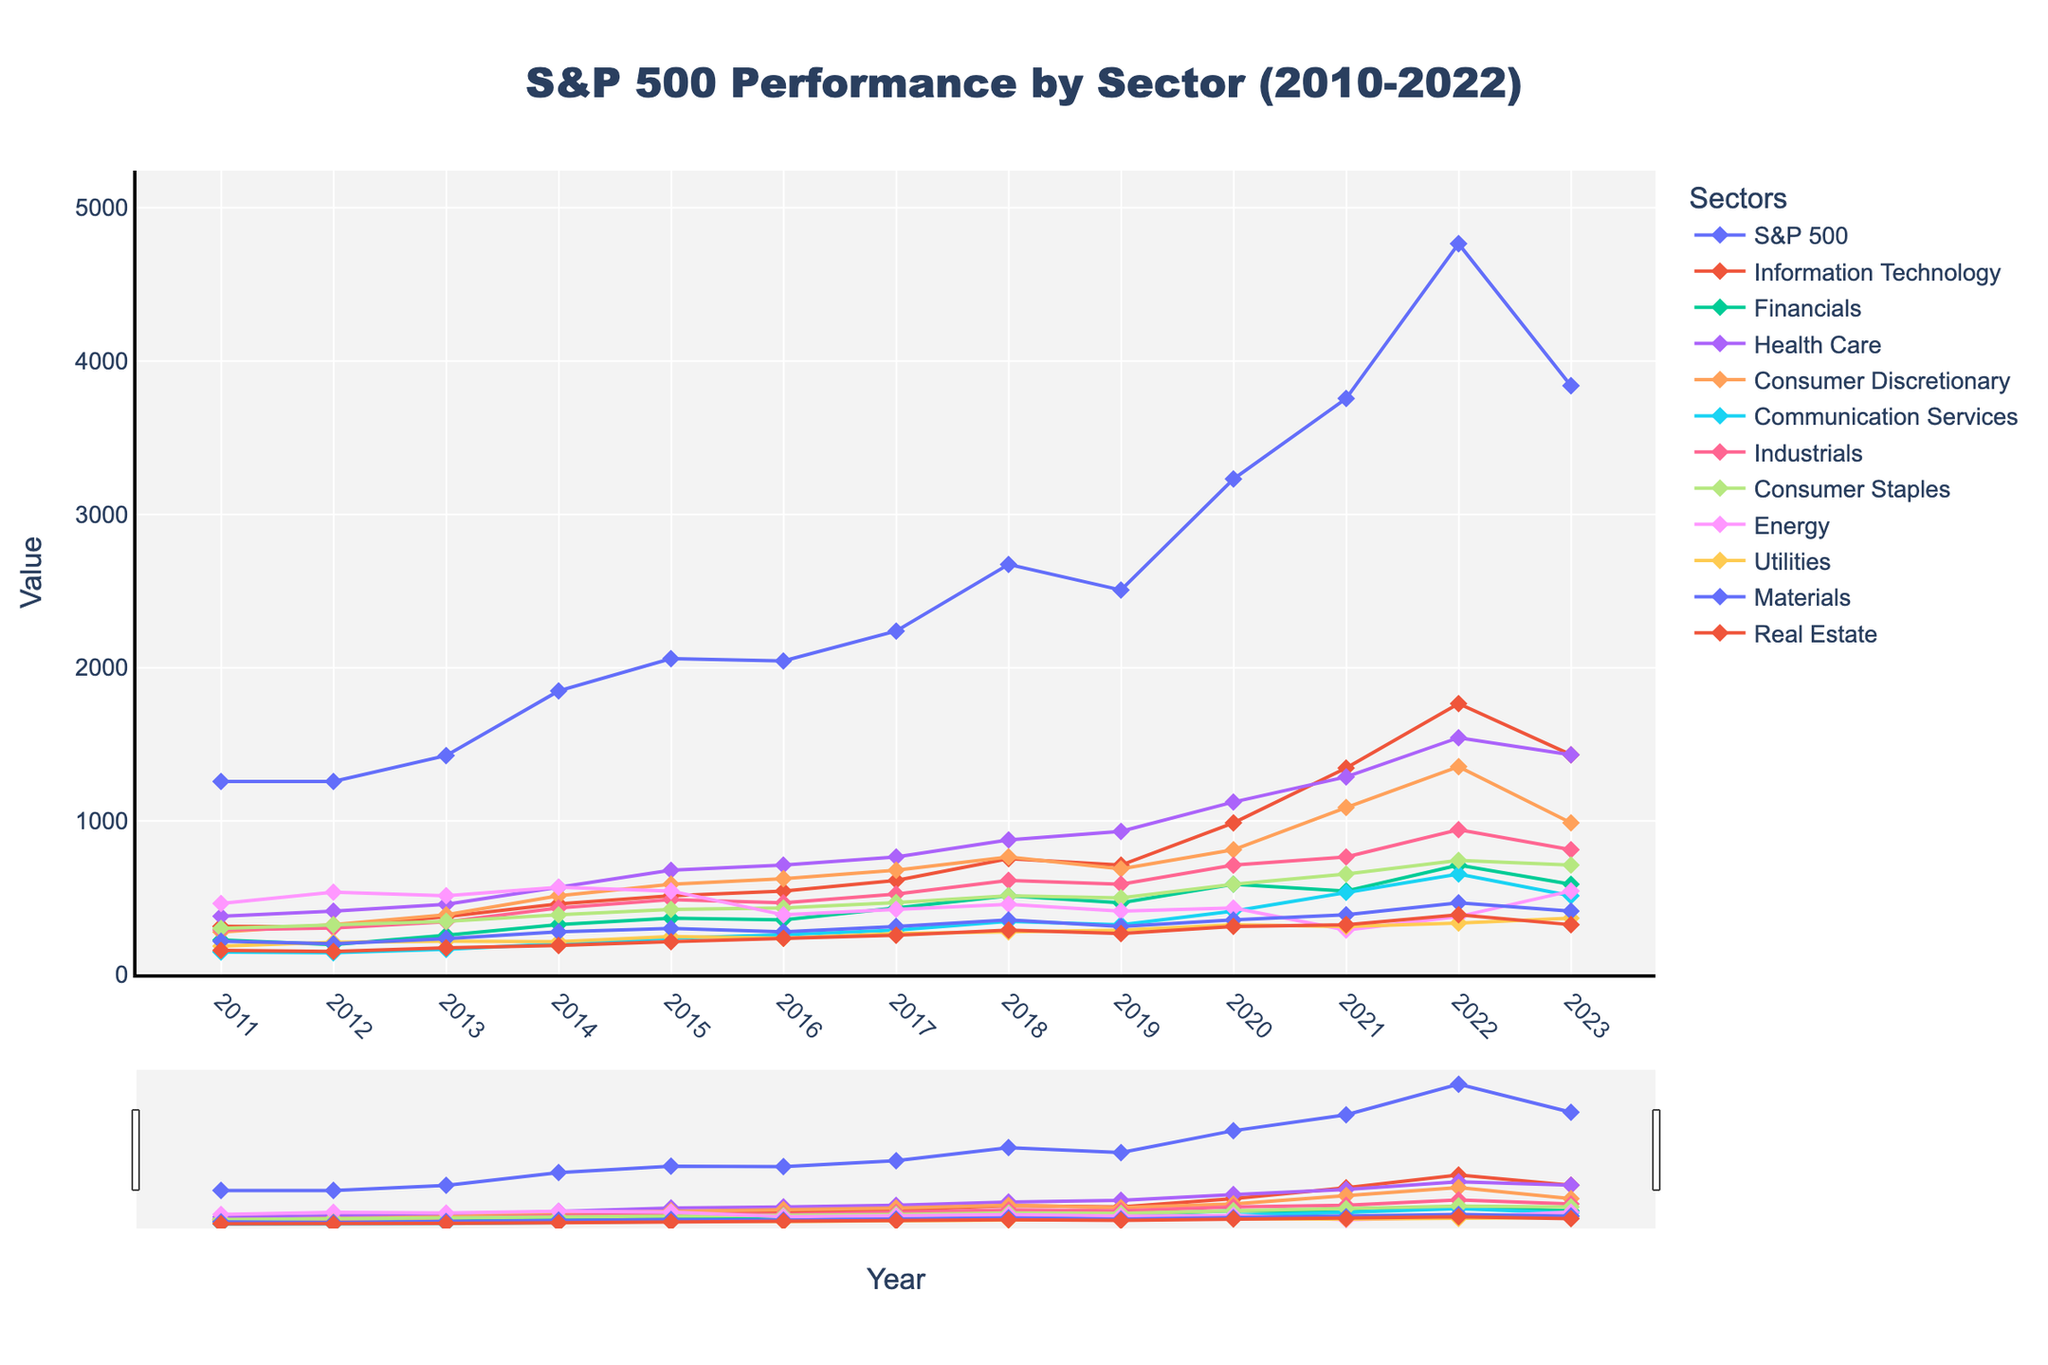What was the peak value of the S&P 500 index between 2010 and 2022? The chart shows the S&P 500 values over time. The highest point on the S&P 500 line is the peak value.
Answer: 4766.18 Which sector showed the most significant increase in value from 2010 to 2022? To determine the sector with the most significant increase, find the difference between the values in 2022 and 2010 for each sector. The largest difference indicates the most significant increase.
Answer: Information Technology Which year did the Health Care sector surpass a value of 1000? Look at the Health Care line on the chart and observe the point where it crosses the value of 1000. Check the corresponding year.
Answer: 2019 Which sector had the lowest value in 2022? Scan the end of the timeline (2022) and compare the final values of each sector. The sector with the lowest value is the answer.
Answer: Real Estate By how much did the Energy sector value change from its peak in 2017 to its lowest point thereafter? Identify the Energy sector's peak value in 2017 and its lowest subsequent value by visually scanning the timeline. Subtract the lowest value from the peak value to get the difference.
Answer: 376.54 What trend is observed in the value of the Financials sector from 2010 to 2022? Observe the line representing the Financials sector over the years. Note whether it generally increases, decreases, or fluctuates.
Answer: Generally increases with fluctuations Which sector was closest in value to the S&P 500 index in 2020? Look at the values for each sector in 2020 and compare them to the S&P 500 value. Find the closest value.
Answer: Information Technology How did the Consumer Discretionary sector perform between 2018 and 2022? Track the Consumer Discretionary line from 2018 to 2022 and observe the trend. Note any increases, decreases, or stability.
Answer: Increased What was the average value increase per year for the Industrials sector from 2010 to 2017? Calculate the total increase for the Industrials sector from 2010 to 2017 and then divide by the number of years (2017-2010). Detailed calculations: The value in 2017 (612.34) minus the value in 2010 (289.26) gives 323.08. Dividing by 7 years ≈ 46.15 per year.
Answer: ≈ 46.15 Which sector had the steepest decline in value from 2021 to 2022? Compare the values of each sector between 2021 and 2022 and identify the largest decrease by subtracting the 2022 value from the 2021 value.
Answer: Information Technology 